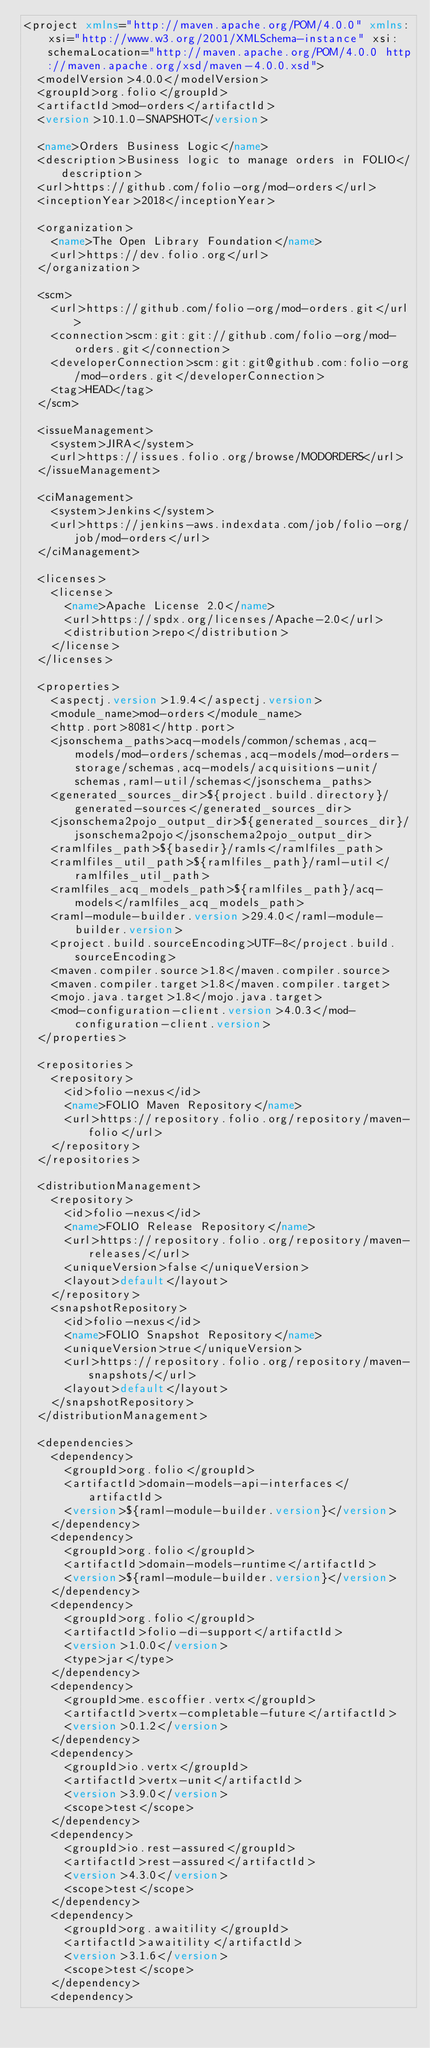<code> <loc_0><loc_0><loc_500><loc_500><_XML_><project xmlns="http://maven.apache.org/POM/4.0.0" xmlns:xsi="http://www.w3.org/2001/XMLSchema-instance" xsi:schemaLocation="http://maven.apache.org/POM/4.0.0 http://maven.apache.org/xsd/maven-4.0.0.xsd">
  <modelVersion>4.0.0</modelVersion>
  <groupId>org.folio</groupId>
  <artifactId>mod-orders</artifactId>
  <version>10.1.0-SNAPSHOT</version>

  <name>Orders Business Logic</name>
  <description>Business logic to manage orders in FOLIO</description>
  <url>https://github.com/folio-org/mod-orders</url>
  <inceptionYear>2018</inceptionYear>

  <organization>
    <name>The Open Library Foundation</name>
    <url>https://dev.folio.org</url>
  </organization>

  <scm>
    <url>https://github.com/folio-org/mod-orders.git</url>
    <connection>scm:git:git://github.com/folio-org/mod-orders.git</connection>
    <developerConnection>scm:git:git@github.com:folio-org/mod-orders.git</developerConnection>
    <tag>HEAD</tag>
  </scm>

  <issueManagement>
    <system>JIRA</system>
    <url>https://issues.folio.org/browse/MODORDERS</url>
  </issueManagement>

  <ciManagement>
    <system>Jenkins</system>
    <url>https://jenkins-aws.indexdata.com/job/folio-org/job/mod-orders</url>
  </ciManagement>

  <licenses>
    <license>
      <name>Apache License 2.0</name>
      <url>https://spdx.org/licenses/Apache-2.0</url>
      <distribution>repo</distribution>
    </license>
  </licenses>

  <properties>
    <aspectj.version>1.9.4</aspectj.version>
    <module_name>mod-orders</module_name>
    <http.port>8081</http.port>
    <jsonschema_paths>acq-models/common/schemas,acq-models/mod-orders/schemas,acq-models/mod-orders-storage/schemas,acq-models/acquisitions-unit/schemas,raml-util/schemas</jsonschema_paths>
    <generated_sources_dir>${project.build.directory}/generated-sources</generated_sources_dir>
    <jsonschema2pojo_output_dir>${generated_sources_dir}/jsonschema2pojo</jsonschema2pojo_output_dir>
    <ramlfiles_path>${basedir}/ramls</ramlfiles_path>
    <ramlfiles_util_path>${ramlfiles_path}/raml-util</ramlfiles_util_path>
    <ramlfiles_acq_models_path>${ramlfiles_path}/acq-models</ramlfiles_acq_models_path>
    <raml-module-builder.version>29.4.0</raml-module-builder.version>
    <project.build.sourceEncoding>UTF-8</project.build.sourceEncoding>
    <maven.compiler.source>1.8</maven.compiler.source>
    <maven.compiler.target>1.8</maven.compiler.target>
    <mojo.java.target>1.8</mojo.java.target>
    <mod-configuration-client.version>4.0.3</mod-configuration-client.version>
  </properties>

  <repositories>
    <repository>
      <id>folio-nexus</id>
      <name>FOLIO Maven Repository</name>
      <url>https://repository.folio.org/repository/maven-folio</url>
    </repository>
  </repositories>

  <distributionManagement>
    <repository>
      <id>folio-nexus</id>
      <name>FOLIO Release Repository</name>
      <url>https://repository.folio.org/repository/maven-releases/</url>
      <uniqueVersion>false</uniqueVersion>
      <layout>default</layout>
    </repository>
    <snapshotRepository>
      <id>folio-nexus</id>
      <name>FOLIO Snapshot Repository</name>
      <uniqueVersion>true</uniqueVersion>
      <url>https://repository.folio.org/repository/maven-snapshots/</url>
      <layout>default</layout>
    </snapshotRepository>
  </distributionManagement>

  <dependencies>
    <dependency>
      <groupId>org.folio</groupId>
      <artifactId>domain-models-api-interfaces</artifactId>
      <version>${raml-module-builder.version}</version>
    </dependency>
    <dependency>
      <groupId>org.folio</groupId>
      <artifactId>domain-models-runtime</artifactId>
      <version>${raml-module-builder.version}</version>
    </dependency>
    <dependency>
      <groupId>org.folio</groupId>
      <artifactId>folio-di-support</artifactId>
      <version>1.0.0</version>
      <type>jar</type>
    </dependency>
    <dependency>
      <groupId>me.escoffier.vertx</groupId>
      <artifactId>vertx-completable-future</artifactId>
      <version>0.1.2</version>
    </dependency>
    <dependency>
      <groupId>io.vertx</groupId>
      <artifactId>vertx-unit</artifactId>
      <version>3.9.0</version>
      <scope>test</scope>
    </dependency>
    <dependency>
      <groupId>io.rest-assured</groupId>
      <artifactId>rest-assured</artifactId>
      <version>4.3.0</version>
      <scope>test</scope>
    </dependency>
    <dependency>
      <groupId>org.awaitility</groupId>
      <artifactId>awaitility</artifactId>
      <version>3.1.6</version>
      <scope>test</scope>
    </dependency>
    <dependency></code> 